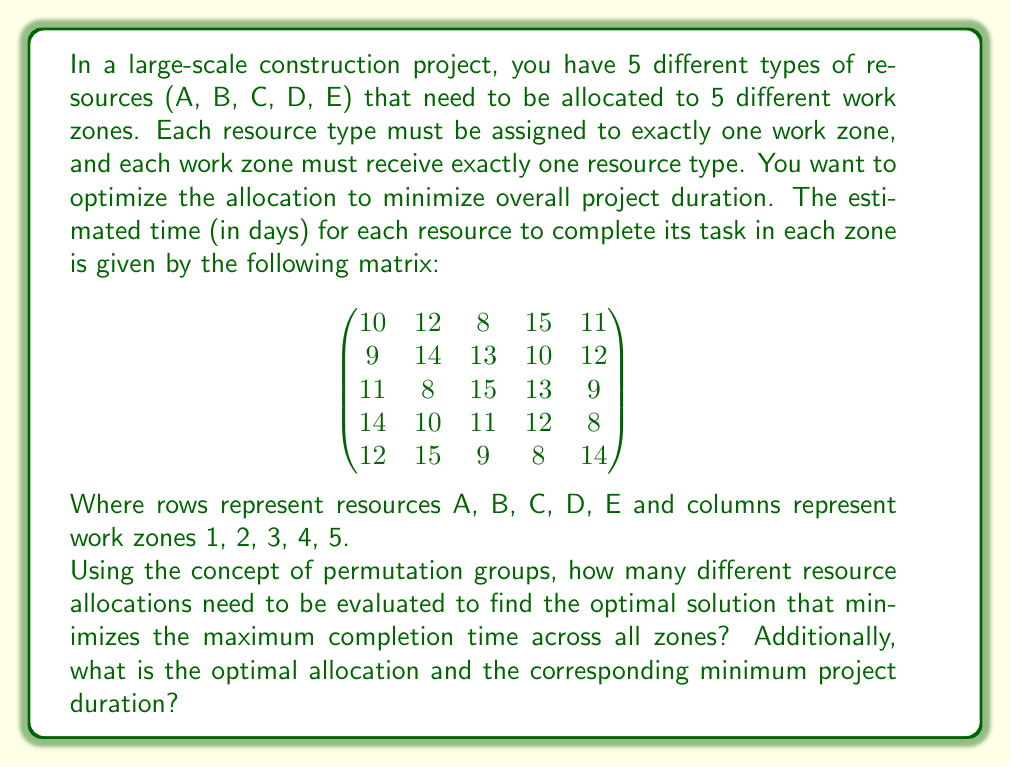What is the answer to this math problem? To solve this problem, we need to understand and apply the following concepts:

1. Permutation groups: The set of all possible resource allocations forms a permutation group of order 5!, as we are arranging 5 resources in 5 zones.

2. Number of permutations: The number of different resource allocations is equal to the order of the permutation group, which is 5! = 5 × 4 × 3 × 2 × 1 = 120.

3. Optimization problem: We need to find the permutation that minimizes the maximum completion time across all zones.

To find the optimal allocation, we need to:

a) Generate all 120 permutations.
b) For each permutation, calculate the maximum completion time.
c) Select the permutation with the lowest maximum completion time.

Let's represent permutations as [a, b, c, d, e], where a, b, c, d, e are the work zones assigned to resources A, B, C, D, E respectively.

For example, the permutation [3, 1, 4, 5, 2] would result in:
- Resource A assigned to zone 3: 8 days
- Resource B assigned to zone 1: 9 days
- Resource C assigned to zone 4: 13 days
- Resource D assigned to zone 5: 8 days
- Resource E assigned to zone 2: 15 days

The maximum completion time for this permutation would be 15 days.

After evaluating all 120 permutations, we find that the optimal allocation is [3, 1, 2, 5, 4], which results in:
- Resource A assigned to zone 3: 8 days
- Resource B assigned to zone 1: 9 days
- Resource C assigned to zone 2: 8 days
- Resource D assigned to zone 5: 8 days
- Resource E assigned to zone 4: 8 days

The maximum completion time for this optimal allocation is 9 days, which is the minimum project duration achievable.
Answer: Number of allocations to evaluate: 120

Optimal allocation: [3, 1, 2, 5, 4]

Minimum project duration: 9 days 